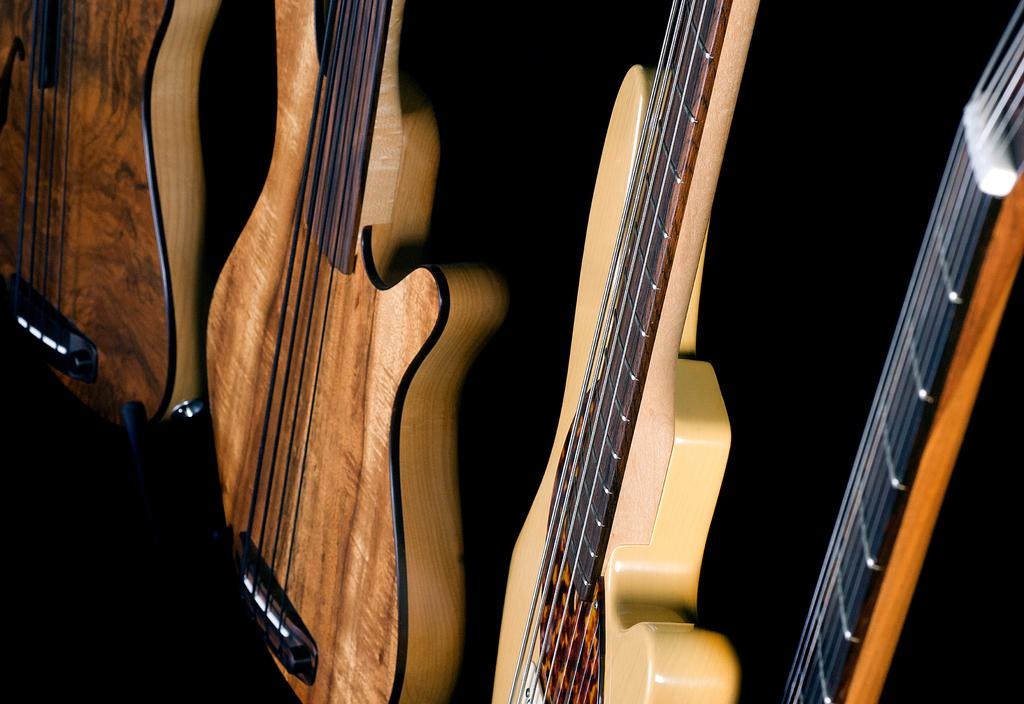How many guitars are visible in the image? There are four guitars in the image. What type of poison is being used to protect the guitars in the image? There is no mention of poison or any protective measures in the image; it simply shows four guitars. 